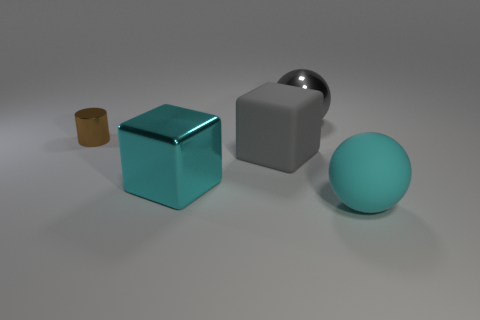Add 2 large gray metallic spheres. How many objects exist? 7 Subtract all cubes. How many objects are left? 3 Subtract 1 gray cubes. How many objects are left? 4 Subtract all spheres. Subtract all large cyan objects. How many objects are left? 1 Add 2 brown cylinders. How many brown cylinders are left? 3 Add 1 large yellow spheres. How many large yellow spheres exist? 1 